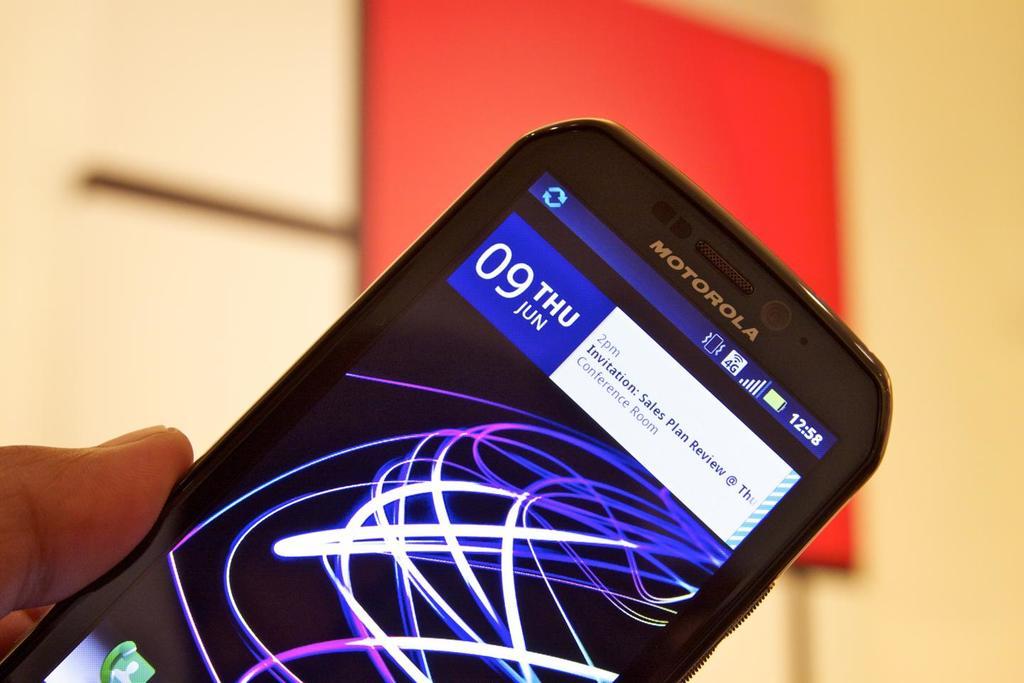What brand of phone?
Your answer should be compact. Motorola. What day does the phone show?
Give a very brief answer. Thursday. 